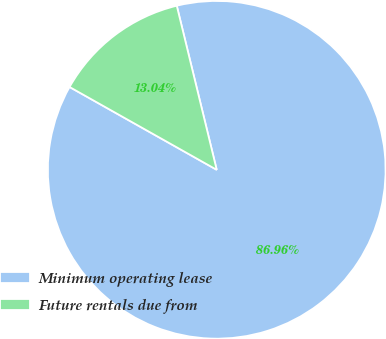Convert chart to OTSL. <chart><loc_0><loc_0><loc_500><loc_500><pie_chart><fcel>Minimum operating lease<fcel>Future rentals due from<nl><fcel>86.96%<fcel>13.04%<nl></chart> 